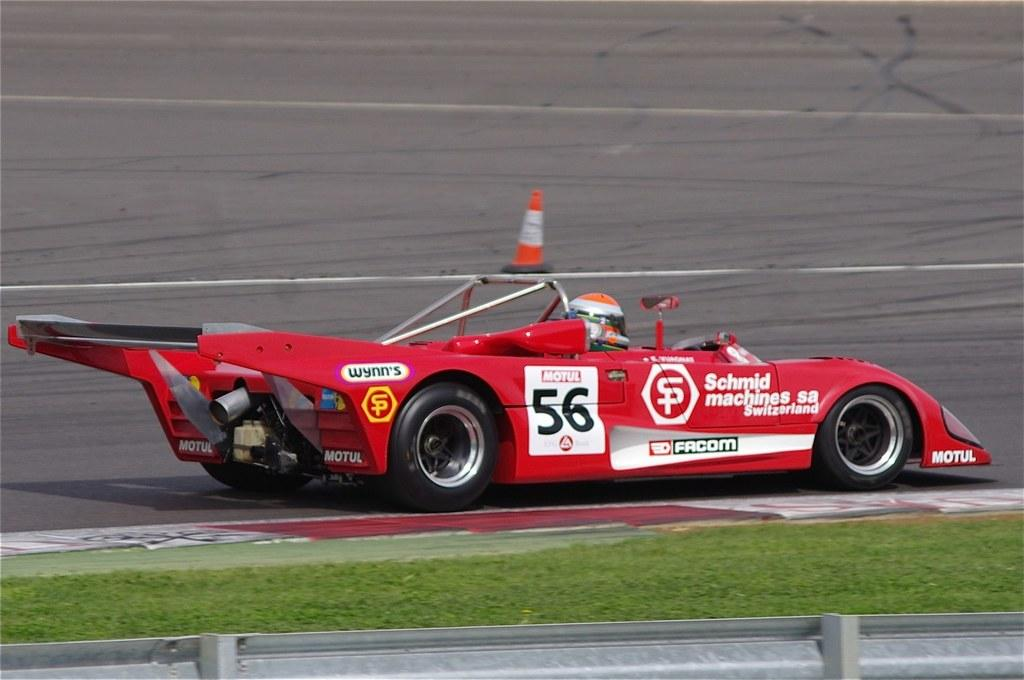What color is the car in the image? The car in the image is red. Who is inside the car? A person is sitting in the car. What is the person wearing? The person is wearing a helmet. Where is the car located? The car is on the road. What can be seen in the background of the image? There is grass visible in the image. What safety feature is present on the road? There is a road cone on the road. What type of plot is the person in the car planning to buy in the image? There is no mention of a plot or any real estate-related activity in the image. 